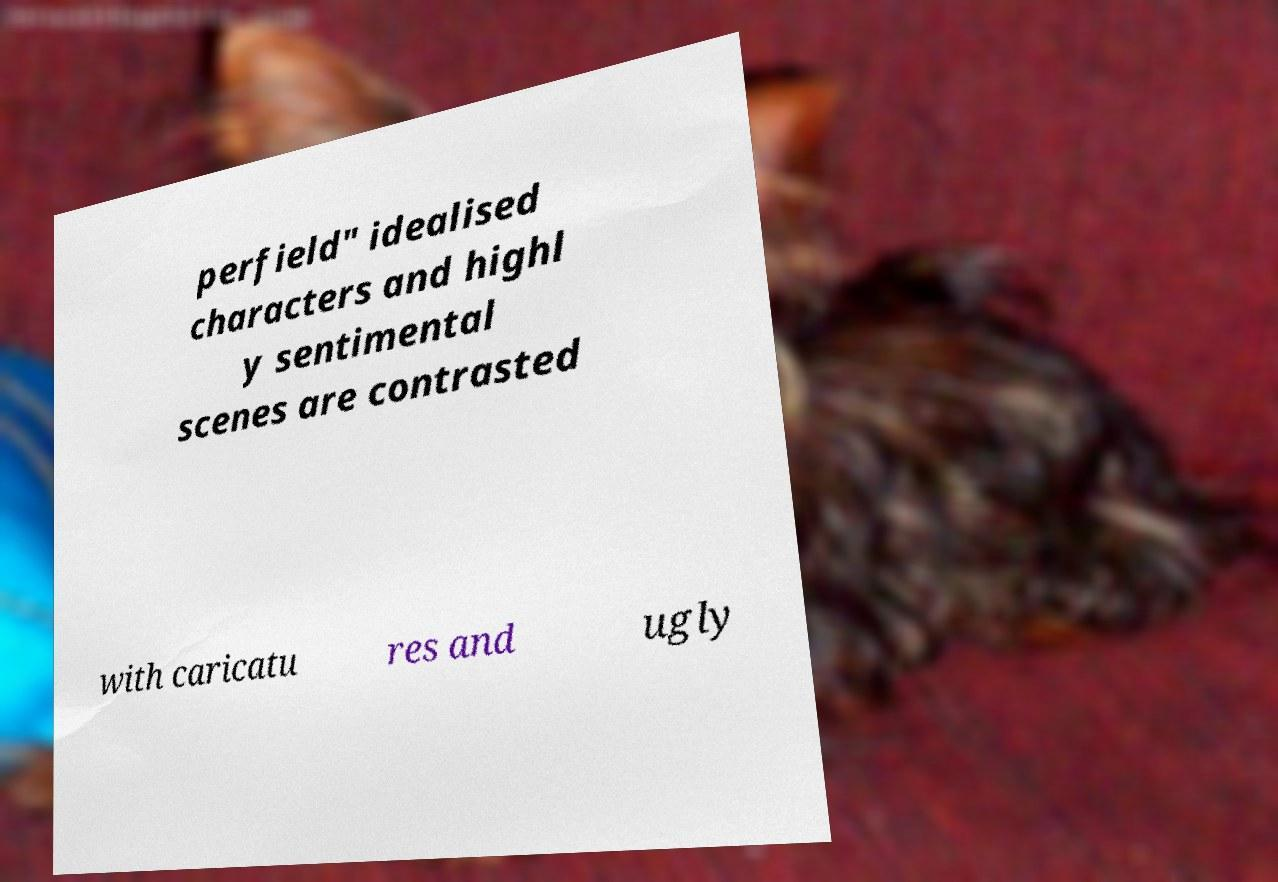Can you read and provide the text displayed in the image?This photo seems to have some interesting text. Can you extract and type it out for me? perfield" idealised characters and highl y sentimental scenes are contrasted with caricatu res and ugly 